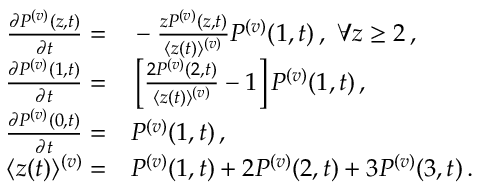Convert formula to latex. <formula><loc_0><loc_0><loc_500><loc_500>\begin{array} { r l } { \frac { \partial P ^ { ( v ) } ( { z } , { t } ) } { \partial t } = } & - \frac { z P ^ { ( v ) } ( { z } , { t } ) } { \langle z ( t ) \rangle ^ { ( v ) } } P ^ { ( v ) } ( { 1 } , { t } ) \, , \forall z \geq 2 \, , } \\ { \frac { \partial P ^ { ( v ) } ( { 1 } , { t } ) } { \partial t } = } & \left [ \frac { 2 P ^ { ( v ) } ( { 2 } , { t } ) } { \langle z ( t ) \rangle ^ { ( v ) } } - 1 \right ] P ^ { ( v ) } ( { 1 } , { t } ) \, , } \\ { \frac { \partial P ^ { ( v ) } ( { 0 } , { t } ) } { \partial t } = } & P ^ { ( v ) } ( { 1 } , { t } ) \, , } \\ { \langle z ( t ) \rangle ^ { ( v ) } = } & P ^ { ( v ) } ( { 1 } , { t } ) + 2 P ^ { ( v ) } ( { 2 } , { t } ) + 3 P ^ { ( v ) } ( { 3 } , { t } ) \, . } \end{array}</formula> 